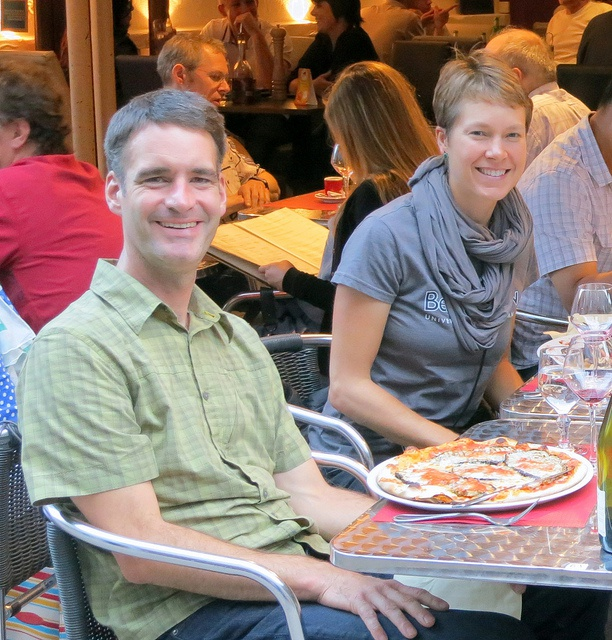Describe the objects in this image and their specific colors. I can see people in tan, darkgray, lightgray, and beige tones, people in tan, gray, and darkgray tones, people in tan, brown, salmon, and black tones, dining table in tan, darkgray, lightpink, and lightgray tones, and people in tan, darkgray, black, and gray tones in this image. 